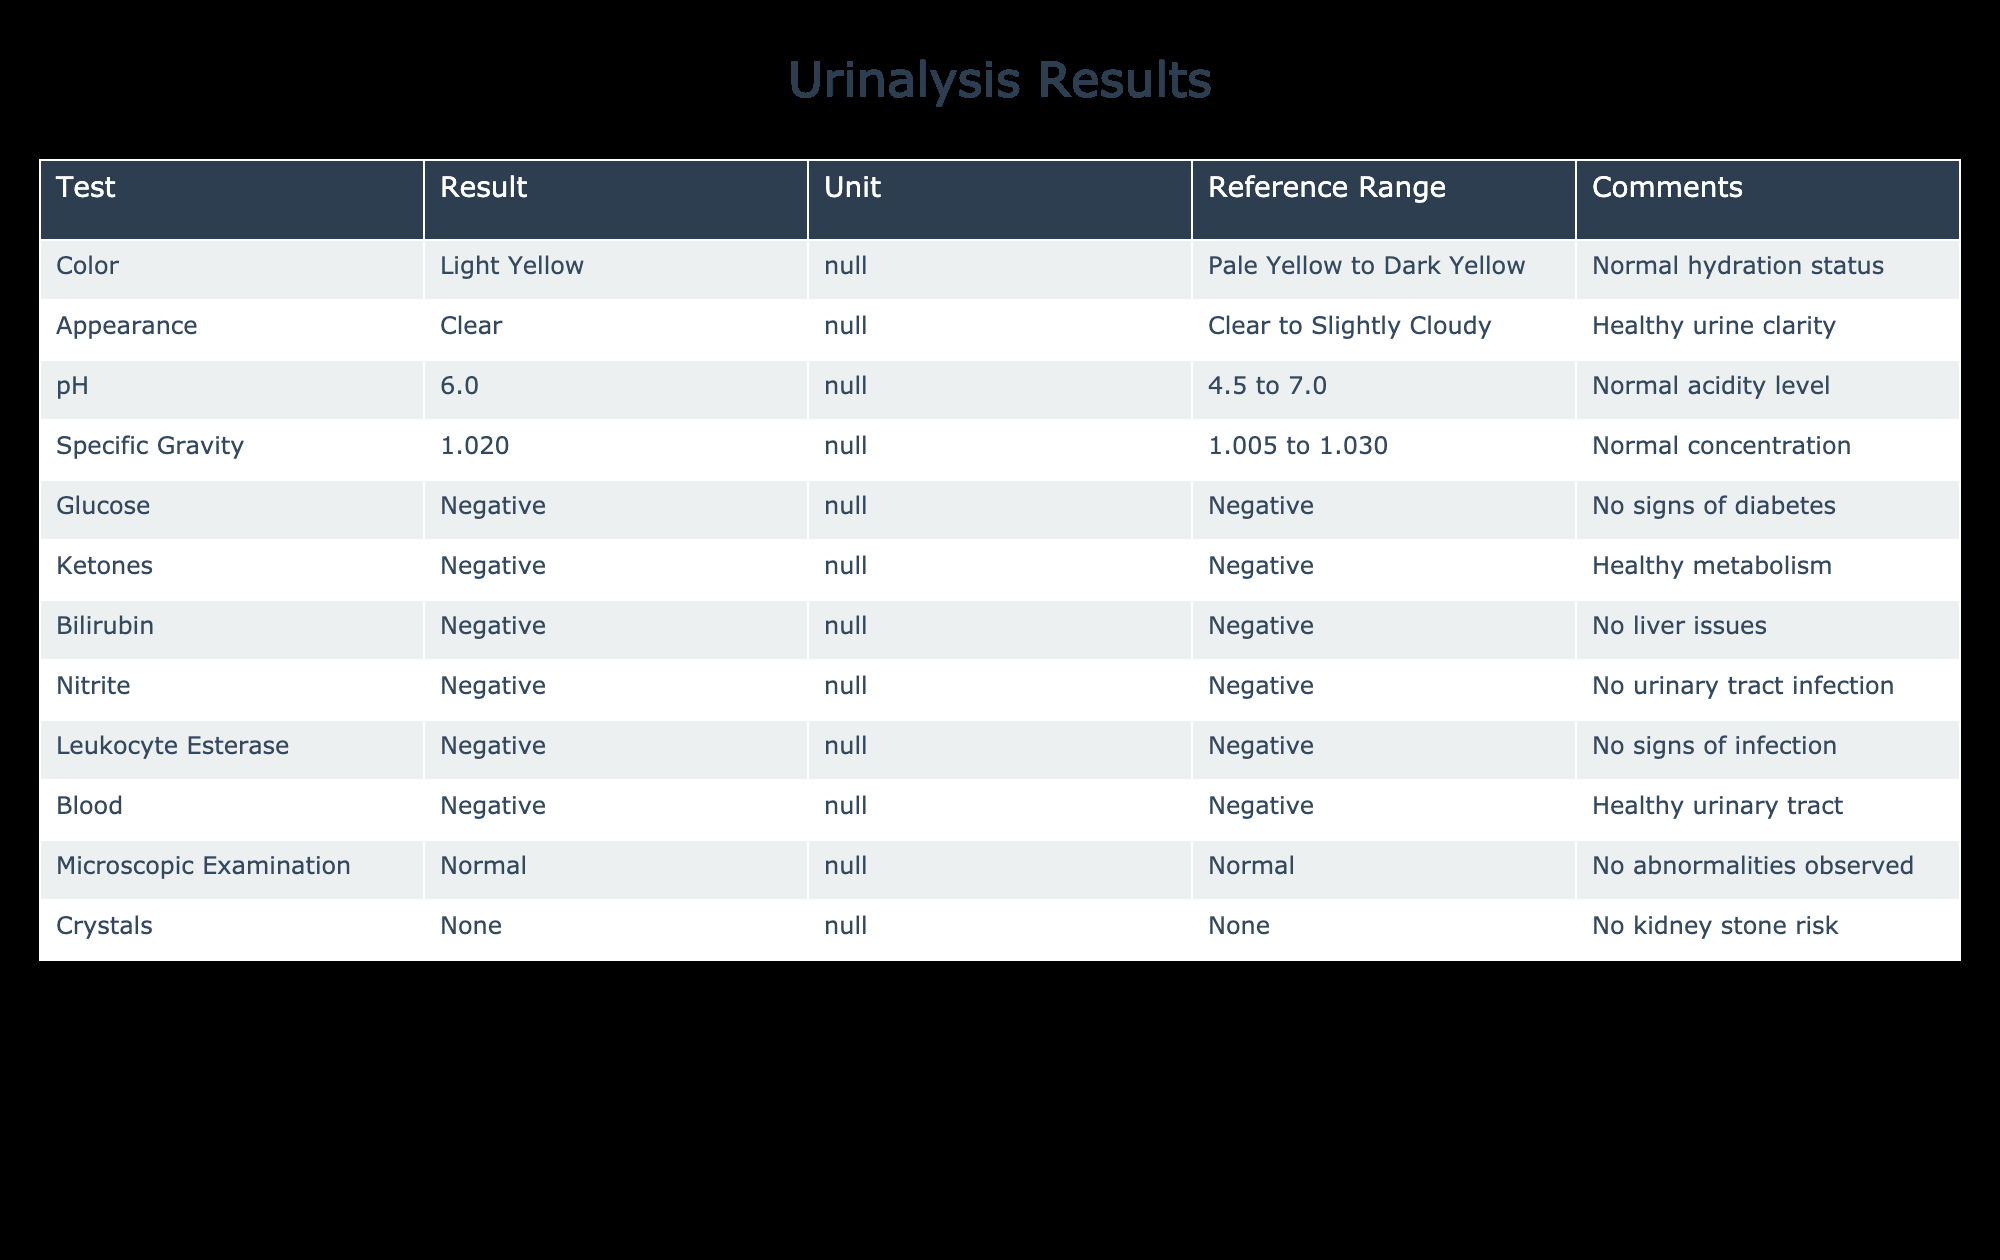What is the specific gravity result? The specific gravity result listed in the table is 1.020.
Answer: 1.020 Is the pH level within the normal range? The pH level is 6.0, which falls within the reference range of 4.5 to 7.0.
Answer: Yes How many tests show a negative result? The table shows a total of 8 tests with negative results: Glucose, Ketones, Bilirubin, Nitrite, Leukocyte Esterase, and Blood.
Answer: 8 What is the color of the urine indicative of? The urine color is light yellow, which is reported as a normal hydration status according to the comments.
Answer: Normal hydration status Which tests indicate no signs of infection? The tests that indicate no signs of infection are Nitrite and Leukocyte Esterase, both of which have negative results.
Answer: Nitrite and Leukocyte Esterase What type of crystals were found in the microscopic examination? The microscopic examination shows no crystals, as indicated by the result “None”.
Answer: None Are there any abnormalities observed in the microscopic examination? The result for microscopic examination is "Normal", indicating that no abnormalities were observed.
Answer: No What is the average pH level of the tested urine? The only pH result in the table is 6.0, so the average is also 6.0 since no other values are present to calculate.
Answer: 6.0 How does the appearance of the urine compare to the reference range? The urine is clear, which is within the reference range of clear to slightly cloudy, indicating healthy urine clarity.
Answer: Healthy urine clarity 